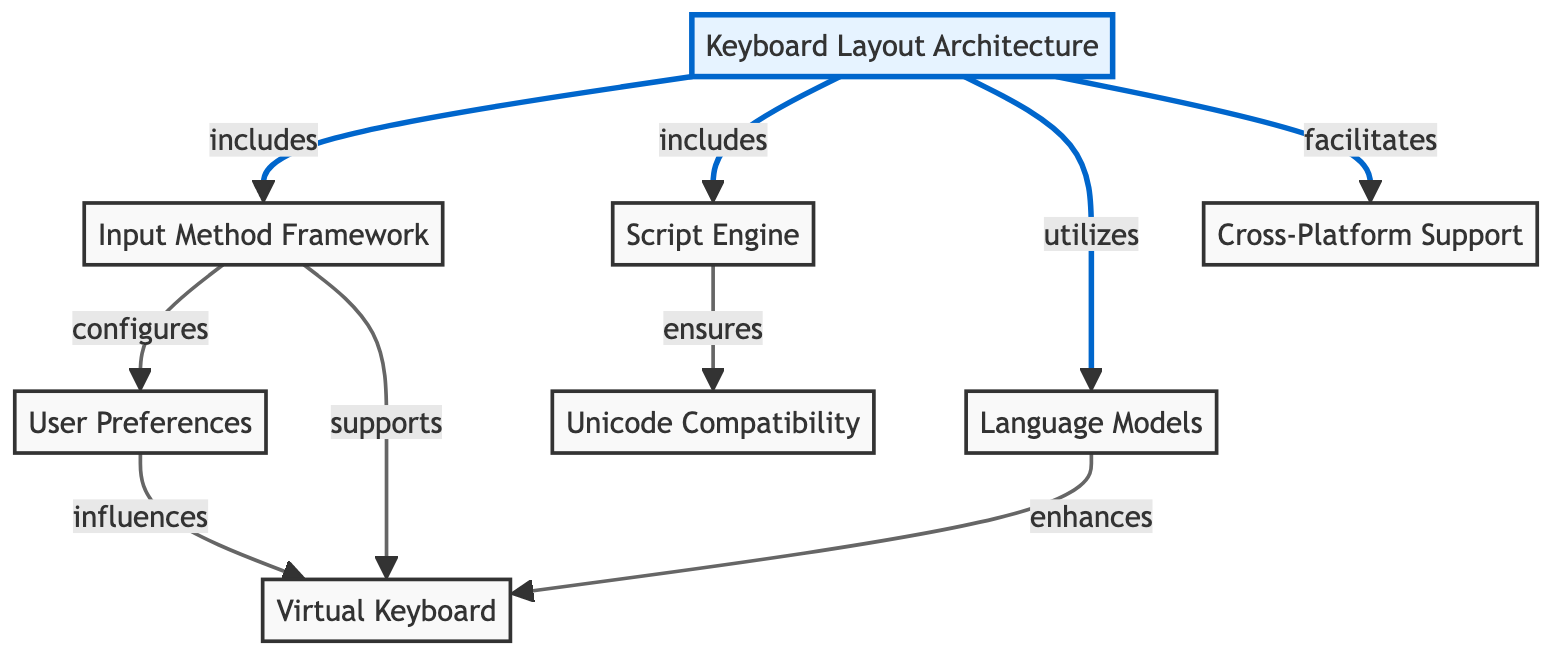What is the main component of the diagram? The main component is labeled "Keyboard Layout Architecture." It is the topmost node in the flowchart and represents the overall system being described.
Answer: Keyboard Layout Architecture How many nodes are included in the diagram? There are eight nodes in total, including the main node and all other connected components. This can be counted directly from the flowchart.
Answer: 8 Which node is connected to the "Input Method Framework"? The node that is connected to the "Input Method Framework" is "Keyboard Layout Architecture," indicating that it is included in this main component.
Answer: Keyboard Layout Architecture What does the "Script Engine" ensure? The "Script Engine" ensures "Unicode Compatibility," as shown by the directed connection between these two nodes in the diagram.
Answer: Unicode Compatibility How does the "User Preferences" influence the system? The "User Preferences" influences the "Virtual Keyboard," which indicates that user settings and preferences play a role in configuring the virtual keyboard outcomes.
Answer: Virtual Keyboard What is a benefit of the "Keyboard Layout Architecture" regarding different platforms? The benefit indicated is "Cross-Platform Support," suggesting that the architecture facilitates the use of the keyboard layout across multiple operating systems or devices.
Answer: Cross-Platform Support Which component enhances the "Virtual Keyboard"? The "Language Models" enhance the "Virtual Keyboard," as implied by the directed edge that shows their supportive relationship in the diagram.
Answer: Language Models How is the "Input Method Framework" related to "User Preferences"? The "Input Method Framework" configures "User Preferences," meaning that it can adapt based on user choices and needs. This is indicated by the directional connection.
Answer: configures What does the "Script Engine" depend on to function properly? The "Script Engine" depends on "Unicode Compatibility" to function properly, as depicted by the relationship showing that the engine ensures this compatibility.
Answer: Unicode Compatibility 